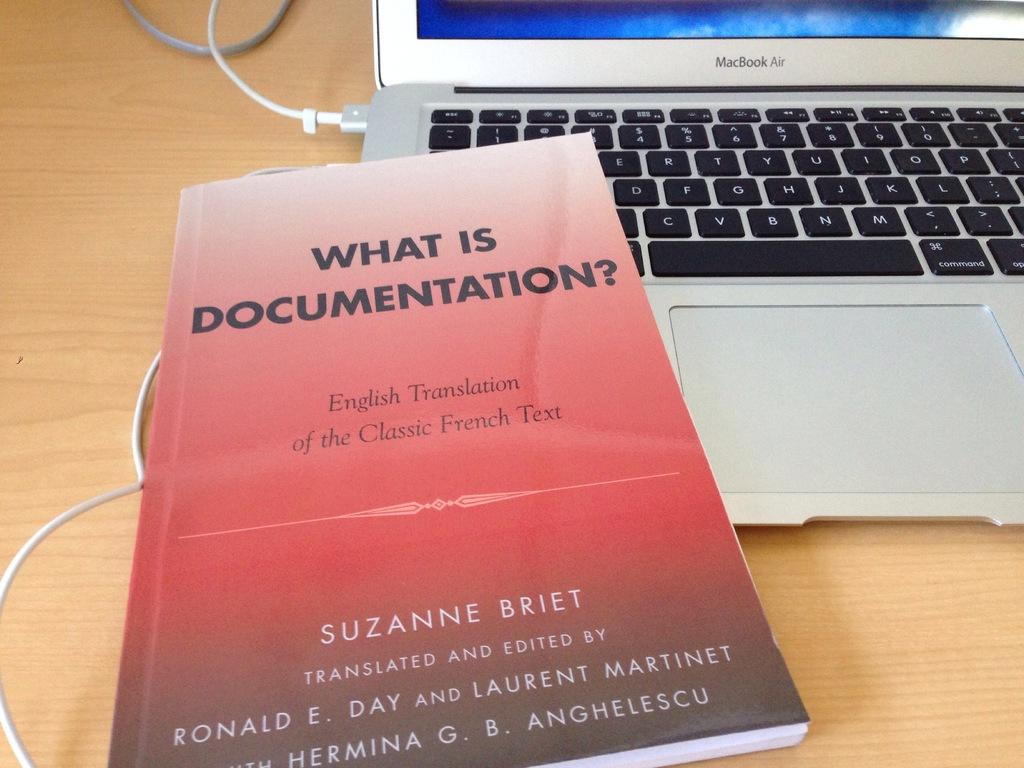<image>
Relay a brief, clear account of the picture shown. Red book titled "What is Documentation" on top of a silver laptop. 